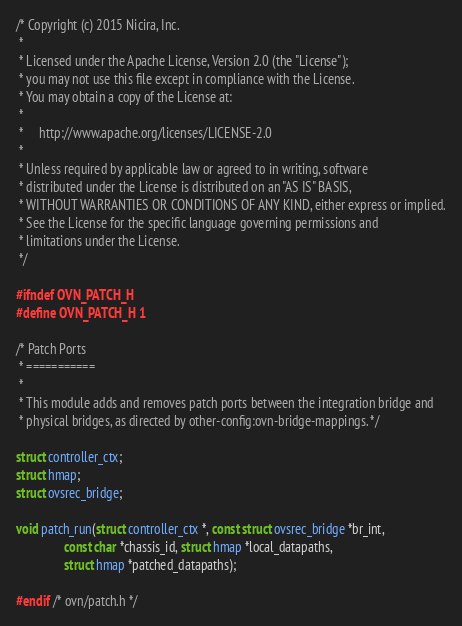Convert code to text. <code><loc_0><loc_0><loc_500><loc_500><_C_>/* Copyright (c) 2015 Nicira, Inc.
 *
 * Licensed under the Apache License, Version 2.0 (the "License");
 * you may not use this file except in compliance with the License.
 * You may obtain a copy of the License at:
 *
 *     http://www.apache.org/licenses/LICENSE-2.0
 *
 * Unless required by applicable law or agreed to in writing, software
 * distributed under the License is distributed on an "AS IS" BASIS,
 * WITHOUT WARRANTIES OR CONDITIONS OF ANY KIND, either express or implied.
 * See the License for the specific language governing permissions and
 * limitations under the License.
 */

#ifndef OVN_PATCH_H
#define OVN_PATCH_H 1

/* Patch Ports
 * ===========
 *
 * This module adds and removes patch ports between the integration bridge and
 * physical bridges, as directed by other-config:ovn-bridge-mappings. */

struct controller_ctx;
struct hmap;
struct ovsrec_bridge;

void patch_run(struct controller_ctx *, const struct ovsrec_bridge *br_int,
               const char *chassis_id, struct hmap *local_datapaths,
               struct hmap *patched_datapaths);

#endif /* ovn/patch.h */
</code> 